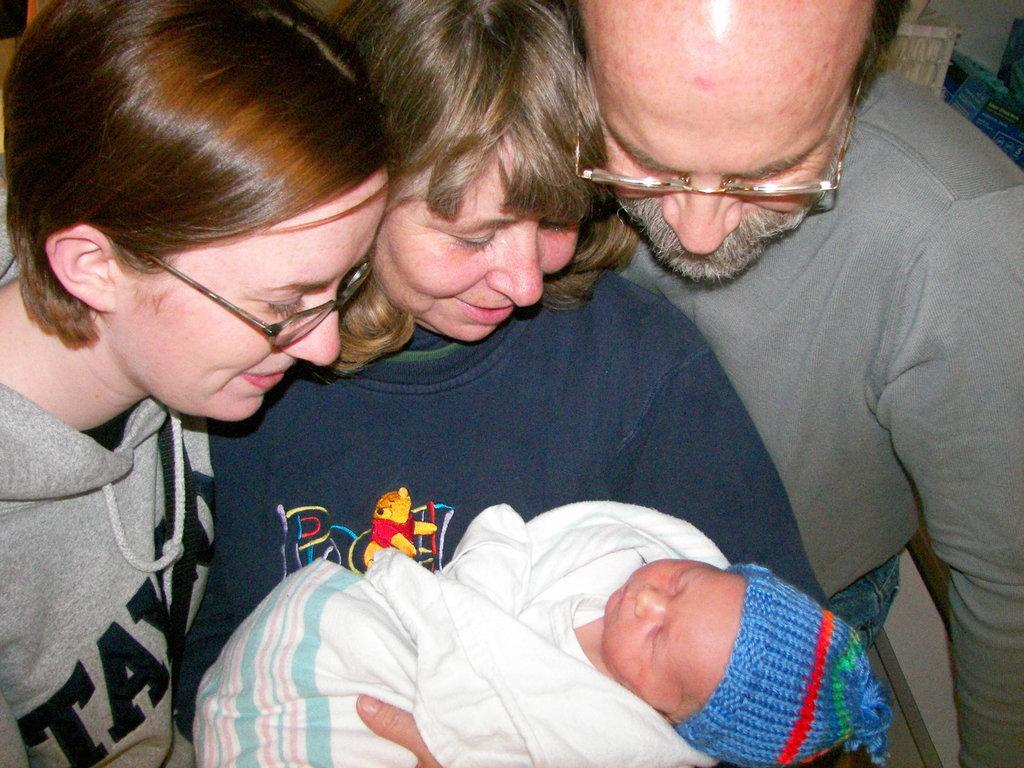How many people are in the image? There are three persons in the image. What are the persons doing in the image? The three persons are standing. What expression do the persons have in the image? The persons are smiling. What is the middle person holding in the image? The middle person is holding a baby. What type of letter can be seen in the hands of the person on the right? There is no letter present in the image; the persons are not holding any letters. How many geese are visible in the image? There are no geese present in the image. 